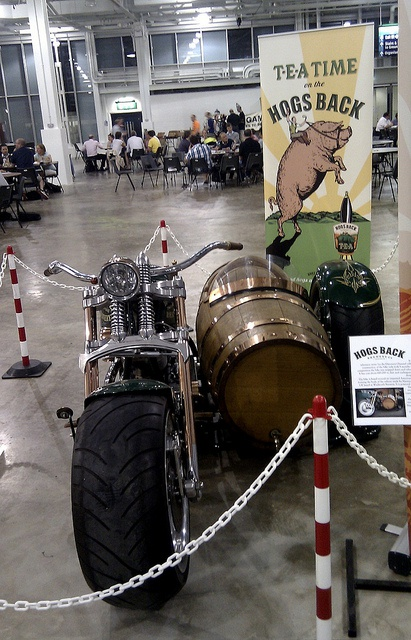Describe the objects in this image and their specific colors. I can see motorcycle in gray, black, darkgray, and lightgray tones, people in gray and black tones, people in gray, black, and darkgray tones, chair in gray, black, and darkgray tones, and chair in gray, black, darkgray, and lightgray tones in this image. 